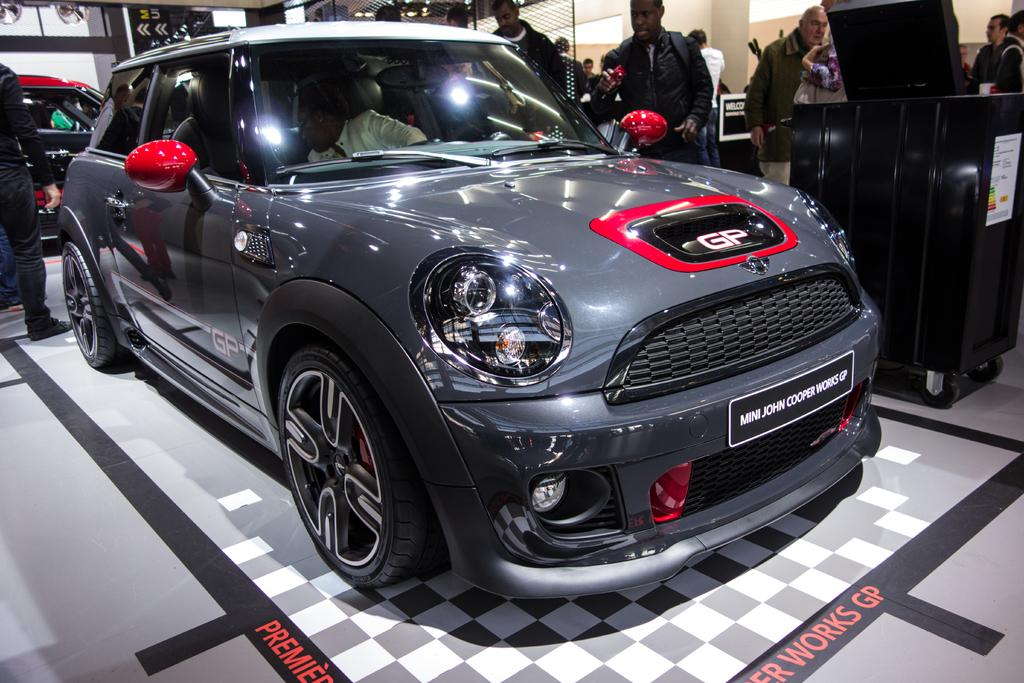What is the main subject in the center of the image? There is a person in a car in the center of the image. What can be seen in the background of the image? There is a wall, a sign board, a pillar, a table, a monitor, vehicles, and people in the background of the image. How many children are playing with the force and twist in the image? There are no children playing with force and twist in the image, as these elements are not present. 